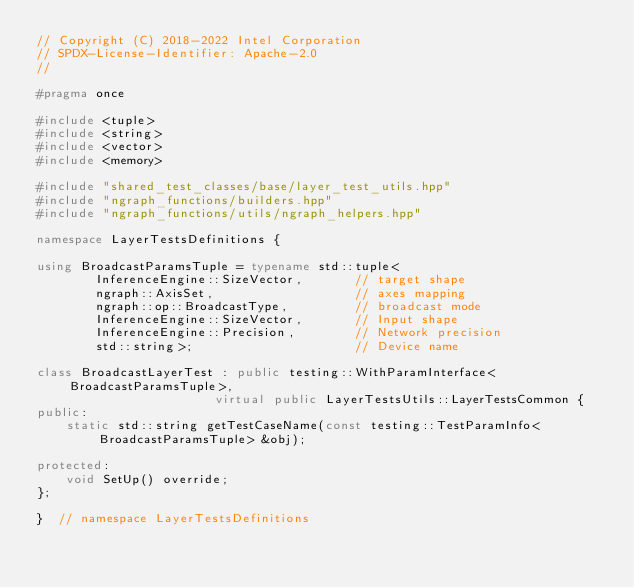Convert code to text. <code><loc_0><loc_0><loc_500><loc_500><_C++_>// Copyright (C) 2018-2022 Intel Corporation
// SPDX-License-Identifier: Apache-2.0
//

#pragma once

#include <tuple>
#include <string>
#include <vector>
#include <memory>

#include "shared_test_classes/base/layer_test_utils.hpp"
#include "ngraph_functions/builders.hpp"
#include "ngraph_functions/utils/ngraph_helpers.hpp"

namespace LayerTestsDefinitions {

using BroadcastParamsTuple = typename std::tuple<
        InferenceEngine::SizeVector,       // target shape
        ngraph::AxisSet,                   // axes mapping
        ngraph::op::BroadcastType,         // broadcast mode
        InferenceEngine::SizeVector,       // Input shape
        InferenceEngine::Precision,        // Network precision
        std::string>;                      // Device name

class BroadcastLayerTest : public testing::WithParamInterface<BroadcastParamsTuple>,
                        virtual public LayerTestsUtils::LayerTestsCommon {
public:
    static std::string getTestCaseName(const testing::TestParamInfo<BroadcastParamsTuple> &obj);

protected:
    void SetUp() override;
};

}  // namespace LayerTestsDefinitions
</code> 